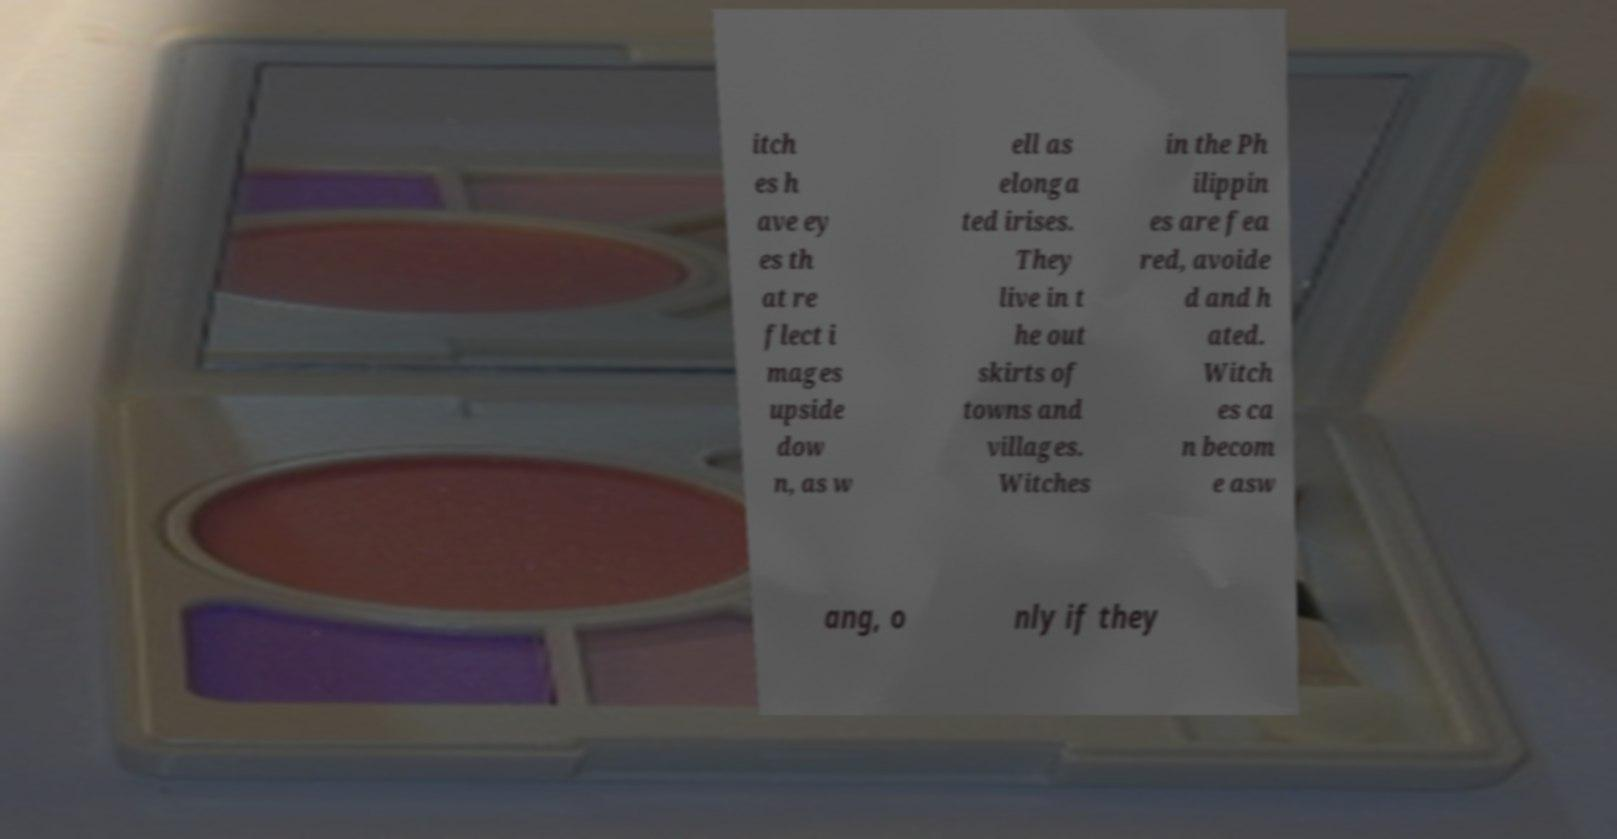Please read and relay the text visible in this image. What does it say? itch es h ave ey es th at re flect i mages upside dow n, as w ell as elonga ted irises. They live in t he out skirts of towns and villages. Witches in the Ph ilippin es are fea red, avoide d and h ated. Witch es ca n becom e asw ang, o nly if they 